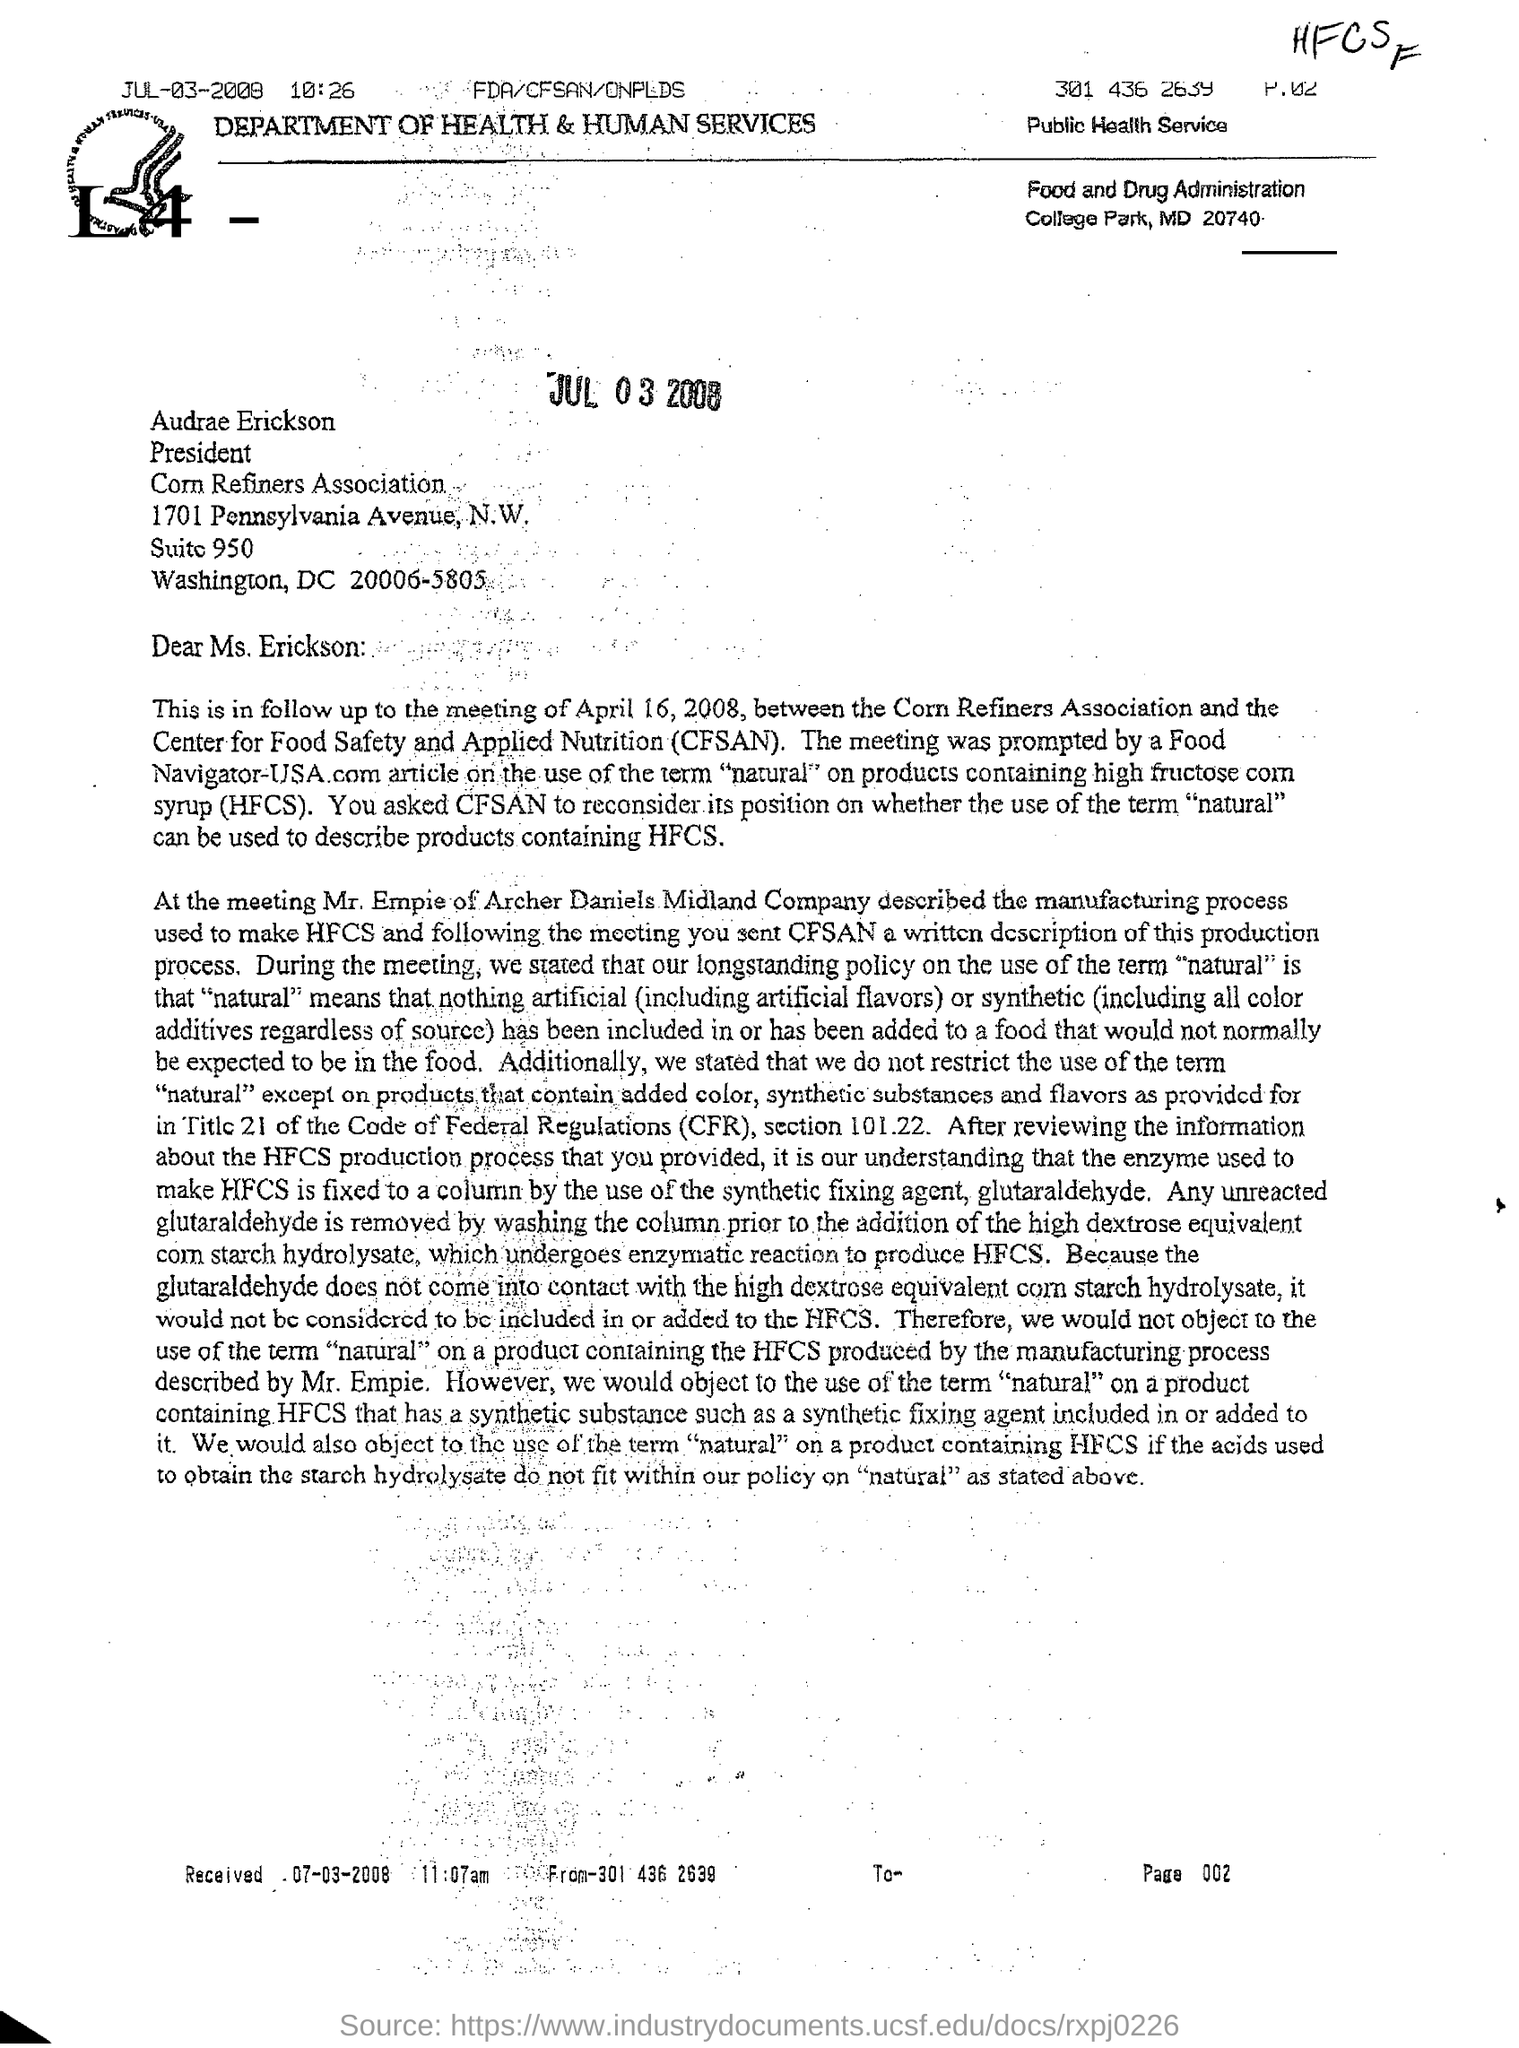What is the full form of CFSAN?
Offer a very short reply. Center for Food Safety and Applied Nutrition. Which department is mentioned in the letter head?
Keep it short and to the point. DEPARTMENT OF HEALTH & HUMAN SERVICES. Who is the President of Corn Refiners Association?
Offer a very short reply. Audrae Erickson. When was this letter received?
Your answer should be very brief. 07-03-2008. 